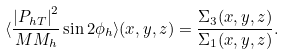Convert formula to latex. <formula><loc_0><loc_0><loc_500><loc_500>\langle \frac { { | P _ { h T } | } ^ { 2 } } { M M _ { h } } \sin 2 \phi _ { h } \rangle ( x , y , z ) = \frac { \Sigma _ { 3 } ( x , y , z ) } { \Sigma _ { 1 } ( x , y , z ) } .</formula> 